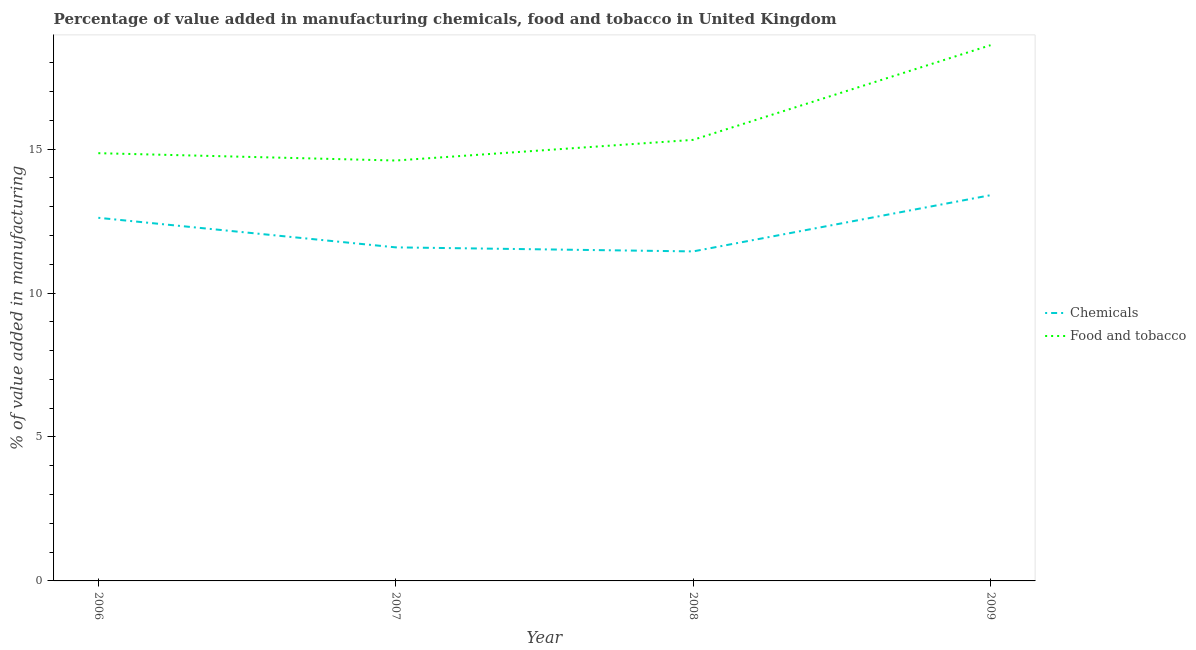How many different coloured lines are there?
Your response must be concise. 2. Is the number of lines equal to the number of legend labels?
Provide a short and direct response. Yes. What is the value added by manufacturing food and tobacco in 2006?
Your response must be concise. 14.86. Across all years, what is the maximum value added by manufacturing food and tobacco?
Offer a terse response. 18.61. Across all years, what is the minimum value added by  manufacturing chemicals?
Your answer should be compact. 11.45. In which year was the value added by manufacturing food and tobacco maximum?
Provide a succinct answer. 2009. What is the total value added by  manufacturing chemicals in the graph?
Your response must be concise. 49.05. What is the difference between the value added by manufacturing food and tobacco in 2006 and that in 2007?
Provide a short and direct response. 0.25. What is the difference between the value added by  manufacturing chemicals in 2006 and the value added by manufacturing food and tobacco in 2007?
Ensure brevity in your answer.  -1.99. What is the average value added by manufacturing food and tobacco per year?
Your response must be concise. 15.85. In the year 2007, what is the difference between the value added by manufacturing food and tobacco and value added by  manufacturing chemicals?
Keep it short and to the point. 3.02. What is the ratio of the value added by  manufacturing chemicals in 2008 to that in 2009?
Offer a terse response. 0.85. Is the value added by manufacturing food and tobacco in 2006 less than that in 2008?
Give a very brief answer. Yes. What is the difference between the highest and the second highest value added by  manufacturing chemicals?
Make the answer very short. 0.79. What is the difference between the highest and the lowest value added by  manufacturing chemicals?
Keep it short and to the point. 1.95. Does the value added by manufacturing food and tobacco monotonically increase over the years?
Ensure brevity in your answer.  No. Is the value added by  manufacturing chemicals strictly greater than the value added by manufacturing food and tobacco over the years?
Give a very brief answer. No. Does the graph contain any zero values?
Your answer should be compact. No. Does the graph contain grids?
Give a very brief answer. No. Where does the legend appear in the graph?
Give a very brief answer. Center right. How are the legend labels stacked?
Offer a very short reply. Vertical. What is the title of the graph?
Provide a short and direct response. Percentage of value added in manufacturing chemicals, food and tobacco in United Kingdom. What is the label or title of the X-axis?
Ensure brevity in your answer.  Year. What is the label or title of the Y-axis?
Offer a terse response. % of value added in manufacturing. What is the % of value added in manufacturing in Chemicals in 2006?
Keep it short and to the point. 12.61. What is the % of value added in manufacturing in Food and tobacco in 2006?
Keep it short and to the point. 14.86. What is the % of value added in manufacturing in Chemicals in 2007?
Your answer should be compact. 11.59. What is the % of value added in manufacturing of Food and tobacco in 2007?
Your response must be concise. 14.6. What is the % of value added in manufacturing of Chemicals in 2008?
Your answer should be very brief. 11.45. What is the % of value added in manufacturing of Food and tobacco in 2008?
Give a very brief answer. 15.32. What is the % of value added in manufacturing of Chemicals in 2009?
Ensure brevity in your answer.  13.4. What is the % of value added in manufacturing in Food and tobacco in 2009?
Keep it short and to the point. 18.61. Across all years, what is the maximum % of value added in manufacturing of Chemicals?
Make the answer very short. 13.4. Across all years, what is the maximum % of value added in manufacturing of Food and tobacco?
Provide a succinct answer. 18.61. Across all years, what is the minimum % of value added in manufacturing in Chemicals?
Your response must be concise. 11.45. Across all years, what is the minimum % of value added in manufacturing of Food and tobacco?
Your answer should be compact. 14.6. What is the total % of value added in manufacturing in Chemicals in the graph?
Give a very brief answer. 49.05. What is the total % of value added in manufacturing in Food and tobacco in the graph?
Provide a short and direct response. 63.39. What is the difference between the % of value added in manufacturing of Chemicals in 2006 and that in 2007?
Your answer should be compact. 1.03. What is the difference between the % of value added in manufacturing of Food and tobacco in 2006 and that in 2007?
Give a very brief answer. 0.25. What is the difference between the % of value added in manufacturing in Chemicals in 2006 and that in 2008?
Keep it short and to the point. 1.17. What is the difference between the % of value added in manufacturing of Food and tobacco in 2006 and that in 2008?
Your response must be concise. -0.46. What is the difference between the % of value added in manufacturing in Chemicals in 2006 and that in 2009?
Offer a terse response. -0.79. What is the difference between the % of value added in manufacturing of Food and tobacco in 2006 and that in 2009?
Your answer should be compact. -3.75. What is the difference between the % of value added in manufacturing in Chemicals in 2007 and that in 2008?
Your answer should be compact. 0.14. What is the difference between the % of value added in manufacturing in Food and tobacco in 2007 and that in 2008?
Offer a very short reply. -0.72. What is the difference between the % of value added in manufacturing of Chemicals in 2007 and that in 2009?
Your answer should be compact. -1.81. What is the difference between the % of value added in manufacturing in Food and tobacco in 2007 and that in 2009?
Your response must be concise. -4.01. What is the difference between the % of value added in manufacturing of Chemicals in 2008 and that in 2009?
Your answer should be compact. -1.95. What is the difference between the % of value added in manufacturing of Food and tobacco in 2008 and that in 2009?
Keep it short and to the point. -3.29. What is the difference between the % of value added in manufacturing in Chemicals in 2006 and the % of value added in manufacturing in Food and tobacco in 2007?
Your answer should be very brief. -1.99. What is the difference between the % of value added in manufacturing in Chemicals in 2006 and the % of value added in manufacturing in Food and tobacco in 2008?
Your response must be concise. -2.71. What is the difference between the % of value added in manufacturing of Chemicals in 2006 and the % of value added in manufacturing of Food and tobacco in 2009?
Provide a short and direct response. -6. What is the difference between the % of value added in manufacturing in Chemicals in 2007 and the % of value added in manufacturing in Food and tobacco in 2008?
Offer a terse response. -3.73. What is the difference between the % of value added in manufacturing in Chemicals in 2007 and the % of value added in manufacturing in Food and tobacco in 2009?
Offer a terse response. -7.02. What is the difference between the % of value added in manufacturing of Chemicals in 2008 and the % of value added in manufacturing of Food and tobacco in 2009?
Ensure brevity in your answer.  -7.16. What is the average % of value added in manufacturing in Chemicals per year?
Your answer should be very brief. 12.26. What is the average % of value added in manufacturing in Food and tobacco per year?
Make the answer very short. 15.85. In the year 2006, what is the difference between the % of value added in manufacturing in Chemicals and % of value added in manufacturing in Food and tobacco?
Ensure brevity in your answer.  -2.24. In the year 2007, what is the difference between the % of value added in manufacturing in Chemicals and % of value added in manufacturing in Food and tobacco?
Give a very brief answer. -3.02. In the year 2008, what is the difference between the % of value added in manufacturing in Chemicals and % of value added in manufacturing in Food and tobacco?
Your answer should be compact. -3.87. In the year 2009, what is the difference between the % of value added in manufacturing in Chemicals and % of value added in manufacturing in Food and tobacco?
Give a very brief answer. -5.21. What is the ratio of the % of value added in manufacturing in Chemicals in 2006 to that in 2007?
Your response must be concise. 1.09. What is the ratio of the % of value added in manufacturing in Food and tobacco in 2006 to that in 2007?
Keep it short and to the point. 1.02. What is the ratio of the % of value added in manufacturing of Chemicals in 2006 to that in 2008?
Keep it short and to the point. 1.1. What is the ratio of the % of value added in manufacturing of Food and tobacco in 2006 to that in 2008?
Your answer should be very brief. 0.97. What is the ratio of the % of value added in manufacturing in Chemicals in 2006 to that in 2009?
Provide a succinct answer. 0.94. What is the ratio of the % of value added in manufacturing of Food and tobacco in 2006 to that in 2009?
Keep it short and to the point. 0.8. What is the ratio of the % of value added in manufacturing of Chemicals in 2007 to that in 2008?
Offer a very short reply. 1.01. What is the ratio of the % of value added in manufacturing of Food and tobacco in 2007 to that in 2008?
Offer a very short reply. 0.95. What is the ratio of the % of value added in manufacturing in Chemicals in 2007 to that in 2009?
Provide a short and direct response. 0.86. What is the ratio of the % of value added in manufacturing in Food and tobacco in 2007 to that in 2009?
Keep it short and to the point. 0.78. What is the ratio of the % of value added in manufacturing of Chemicals in 2008 to that in 2009?
Your answer should be compact. 0.85. What is the ratio of the % of value added in manufacturing of Food and tobacco in 2008 to that in 2009?
Your answer should be very brief. 0.82. What is the difference between the highest and the second highest % of value added in manufacturing of Chemicals?
Your answer should be compact. 0.79. What is the difference between the highest and the second highest % of value added in manufacturing of Food and tobacco?
Your answer should be compact. 3.29. What is the difference between the highest and the lowest % of value added in manufacturing of Chemicals?
Offer a terse response. 1.95. What is the difference between the highest and the lowest % of value added in manufacturing in Food and tobacco?
Offer a terse response. 4.01. 